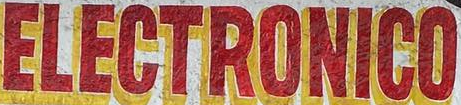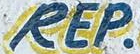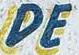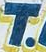What text is displayed in these images sequentially, separated by a semicolon? ELECTRONICO; REP; DE; T 